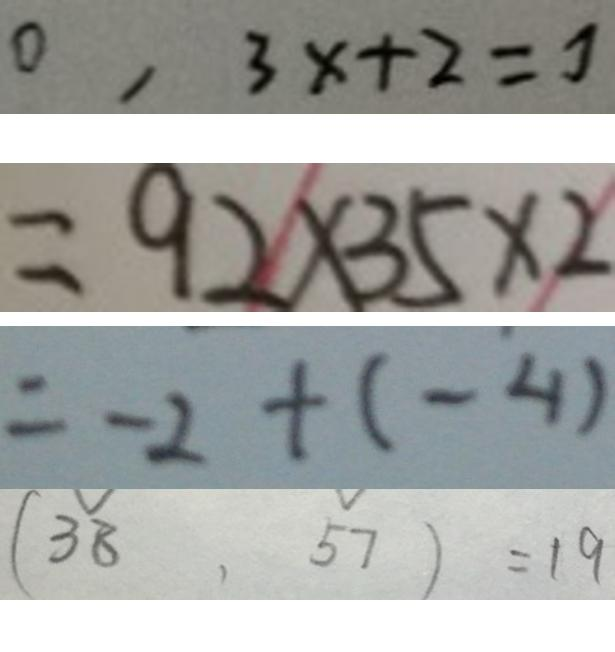Convert formula to latex. <formula><loc_0><loc_0><loc_500><loc_500>0 , 3 x + 2 = 7 
 = 9 2 \times 3 5 \times 2 
 = - 2 + ( - 4 ) 
 ( 3 8 , 5 7 ) = 1 9</formula> 